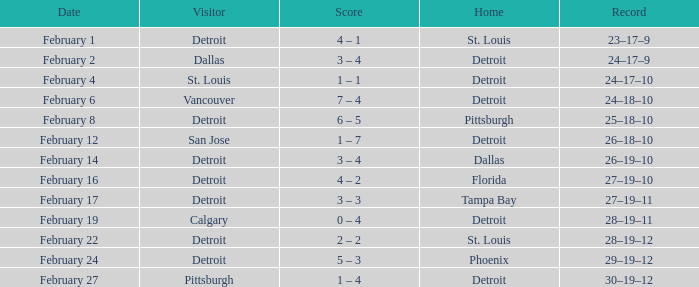What was their record when they were at Pittsburgh? 25–18–10. 